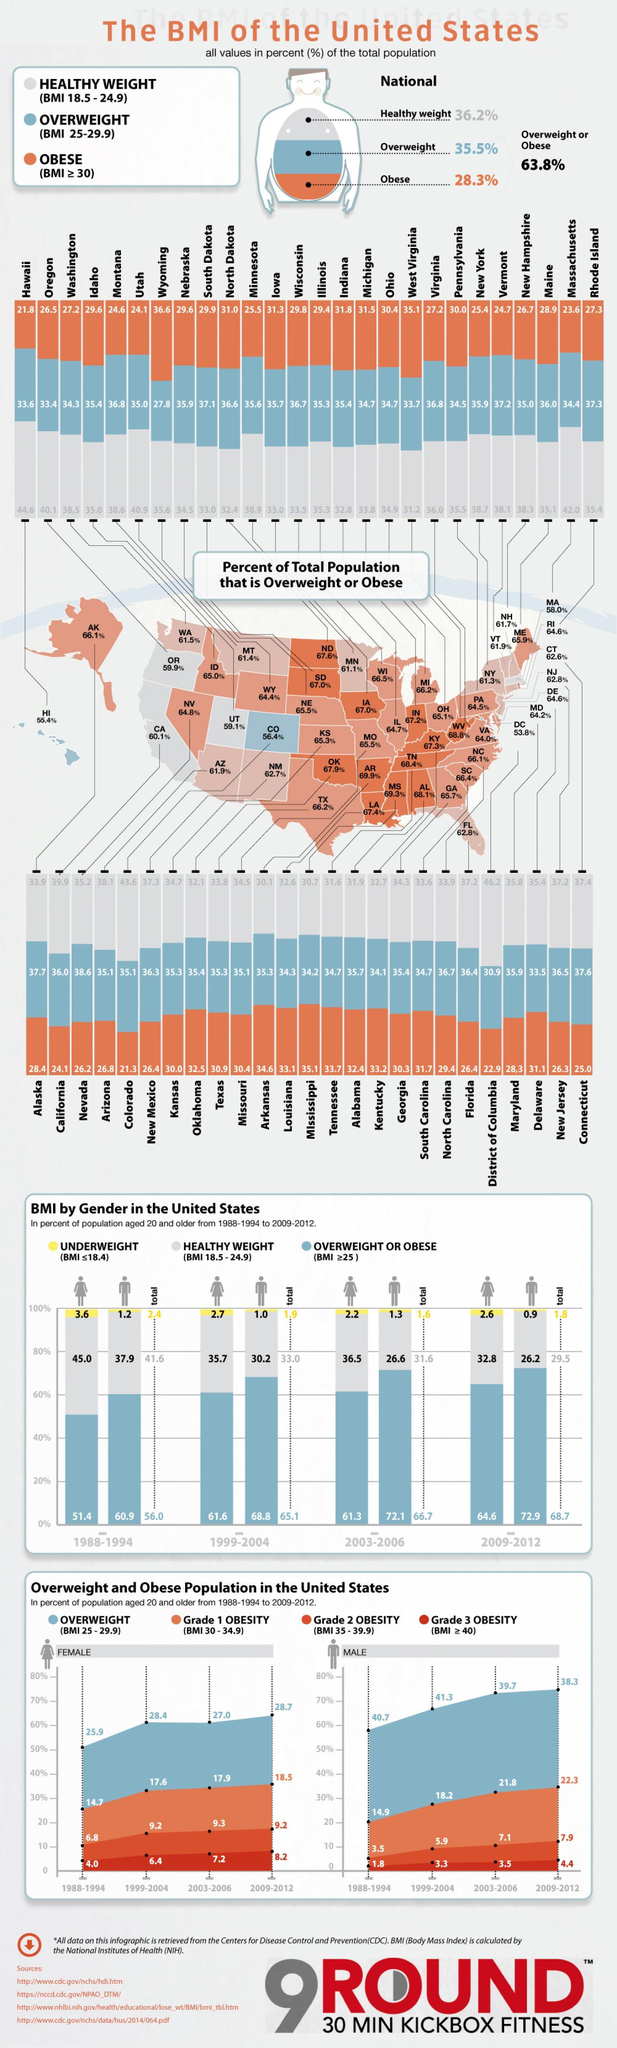What percentage of women were underweight in 1988-1994?
Answer the question with a short phrase. 3.6% What percentage of the total population is obese? 28.3 